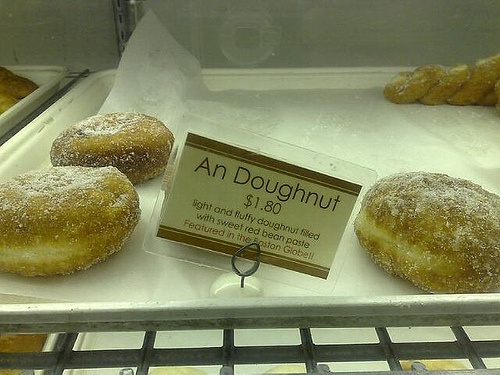Describe the objects in this image and their specific colors. I can see donut in darkgreen and olive tones, donut in darkgreen, olive, and beige tones, donut in darkgreen, olive, beige, and black tones, and donut in darkgreen, olive, and black tones in this image. 